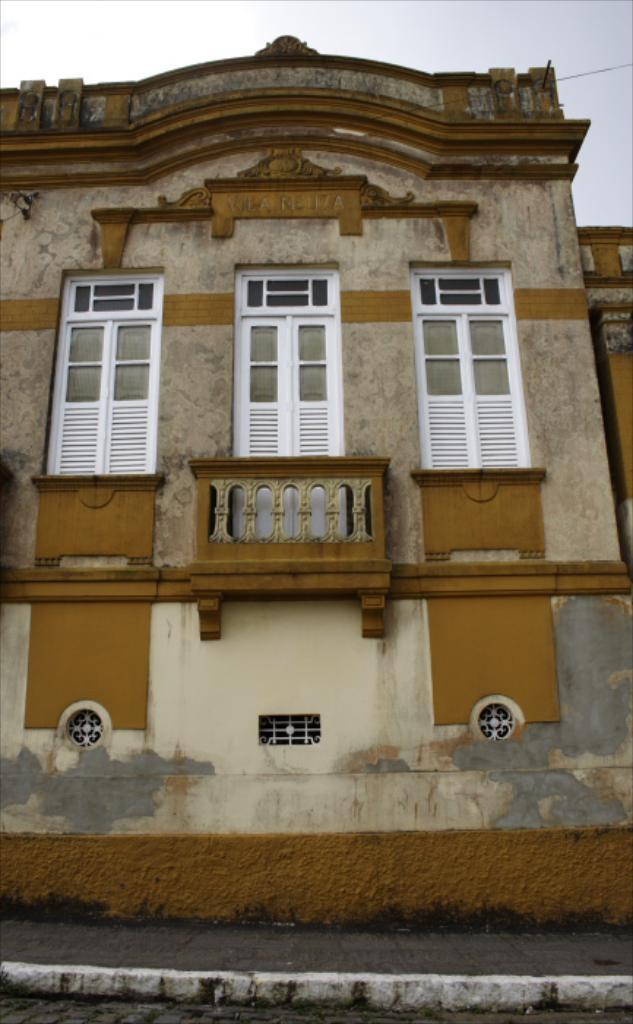Please provide a concise description of this image. In this picture we can observe a building. There are white color windows. We can observe a wire on the right side. In the background there is a sky. 